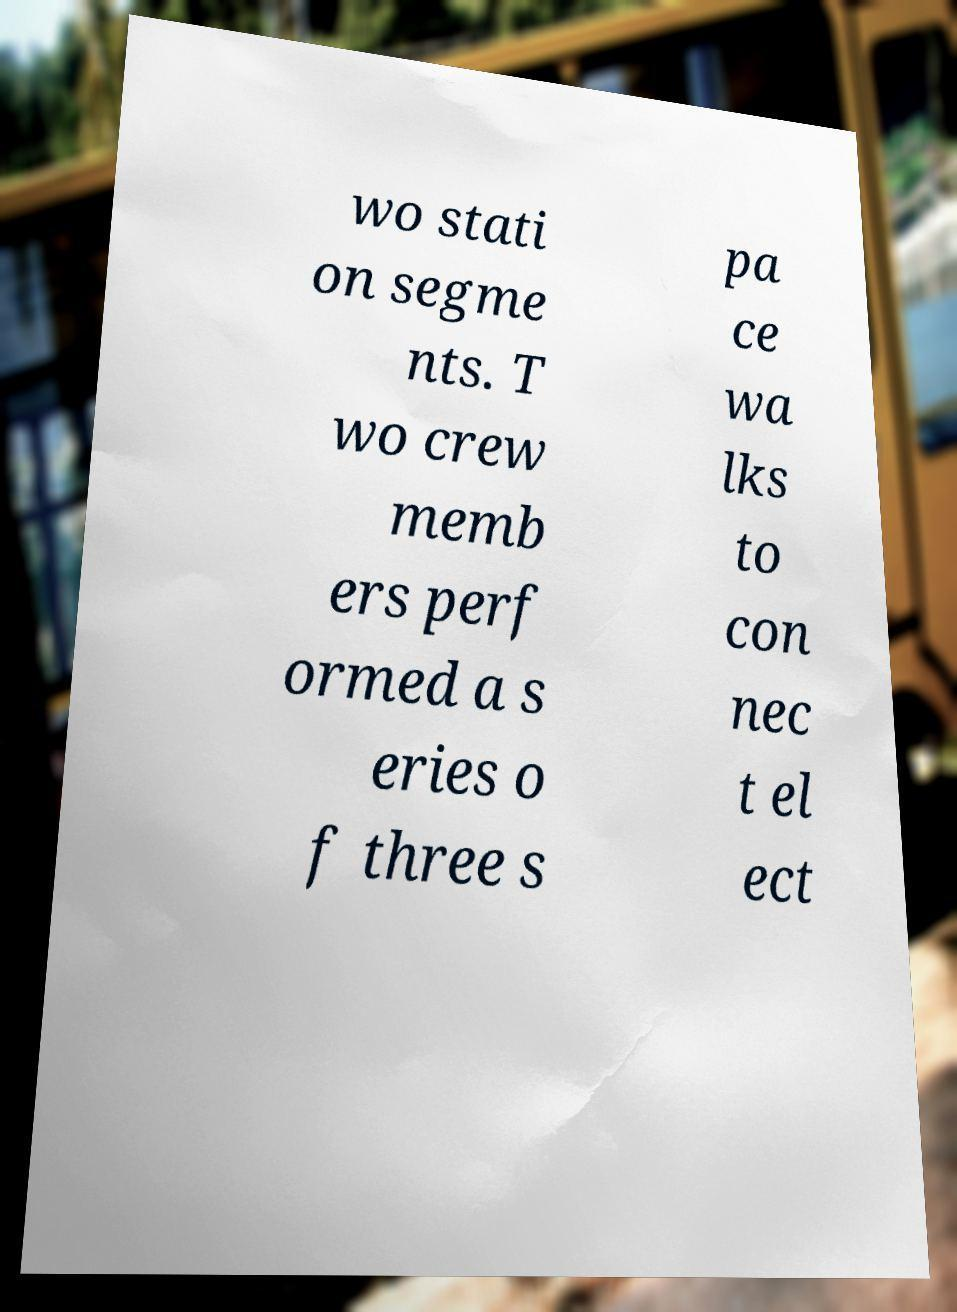I need the written content from this picture converted into text. Can you do that? wo stati on segme nts. T wo crew memb ers perf ormed a s eries o f three s pa ce wa lks to con nec t el ect 